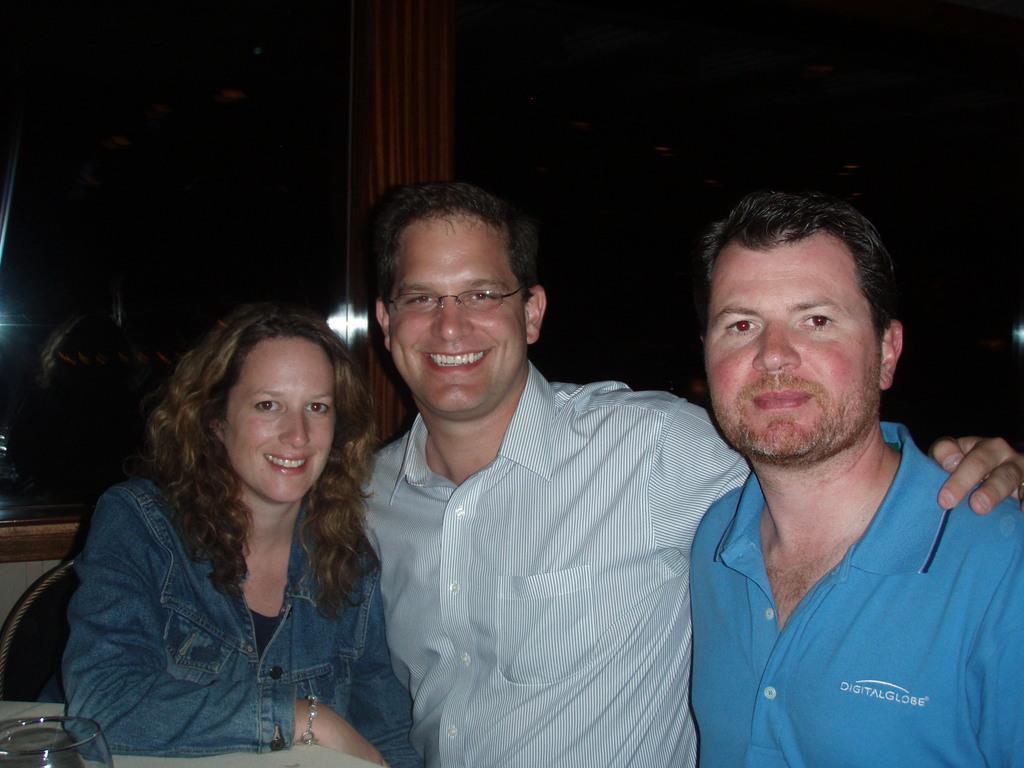Could you give a brief overview of what you see in this image? In this image we can see a man and a woman smiling. We can see the other man on the right. On the left we can see a glass on the table. We can also see the glass window. 